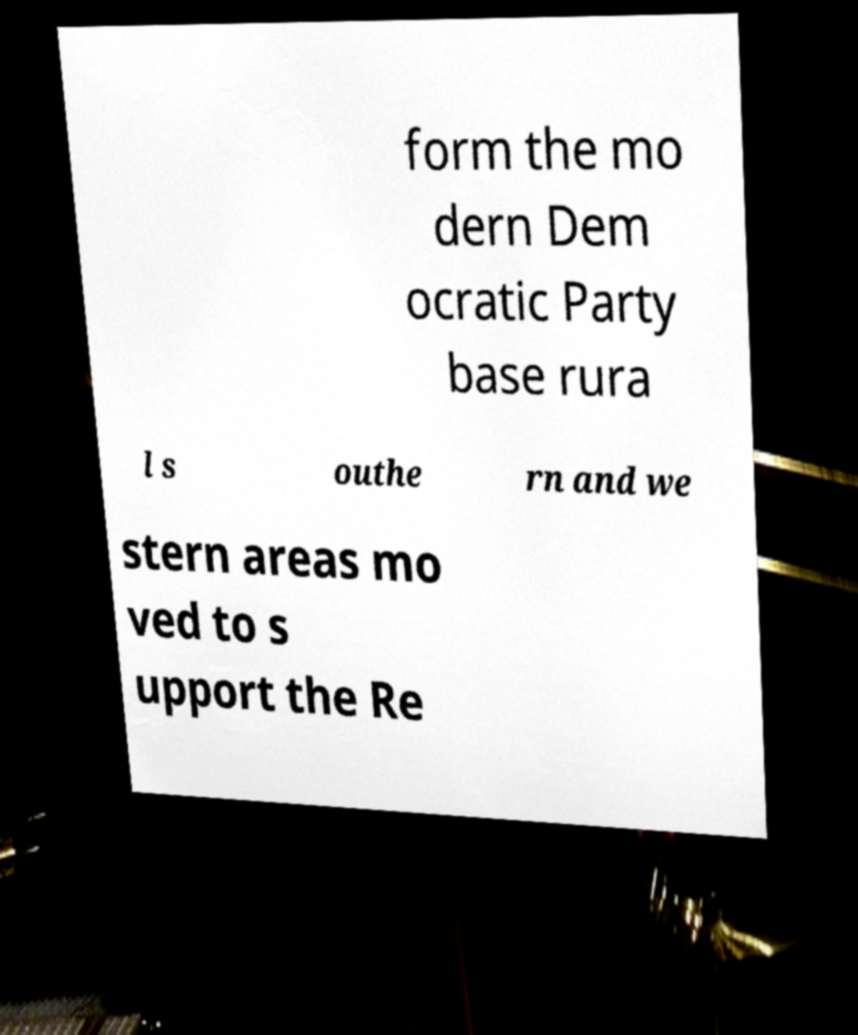There's text embedded in this image that I need extracted. Can you transcribe it verbatim? form the mo dern Dem ocratic Party base rura l s outhe rn and we stern areas mo ved to s upport the Re 